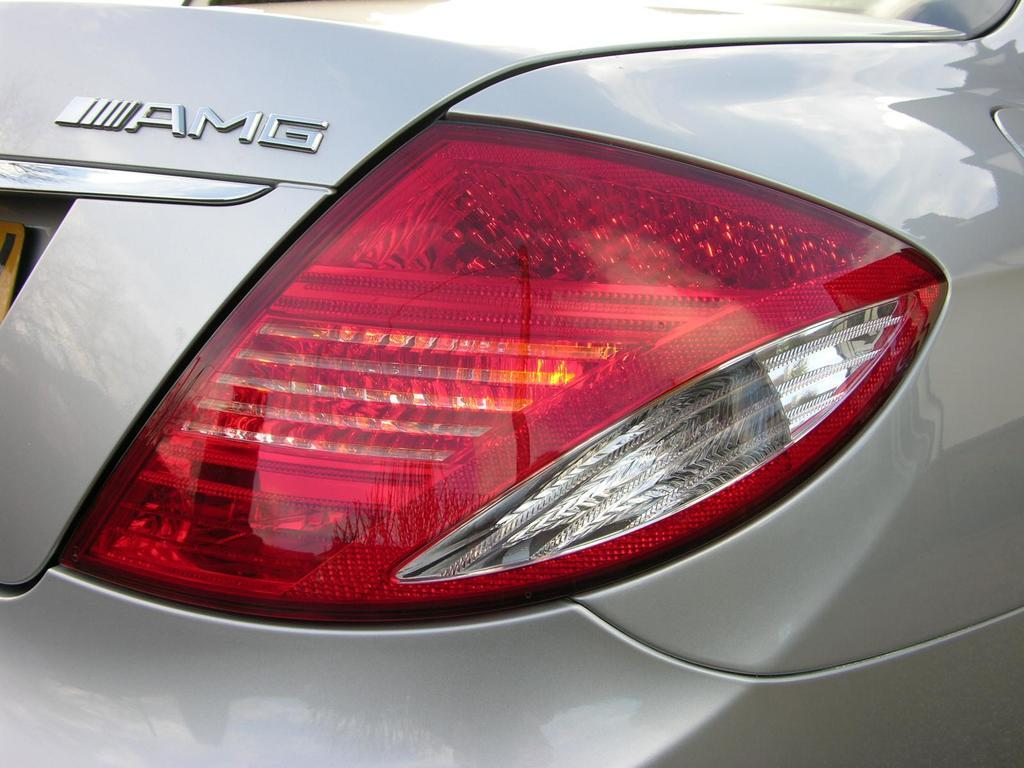What type of light can be seen in the image? There is a tail light visible in the image. What is present on the vehicle in the image? There is a logo on a vehicle in the image. Where is the grandfather sitting during the meeting in the image? There is no grandfather or meeting present in the image. What country is depicted in the background of the image? There is no country depicted in the image; it only features a tail light and a logo on a vehicle. 